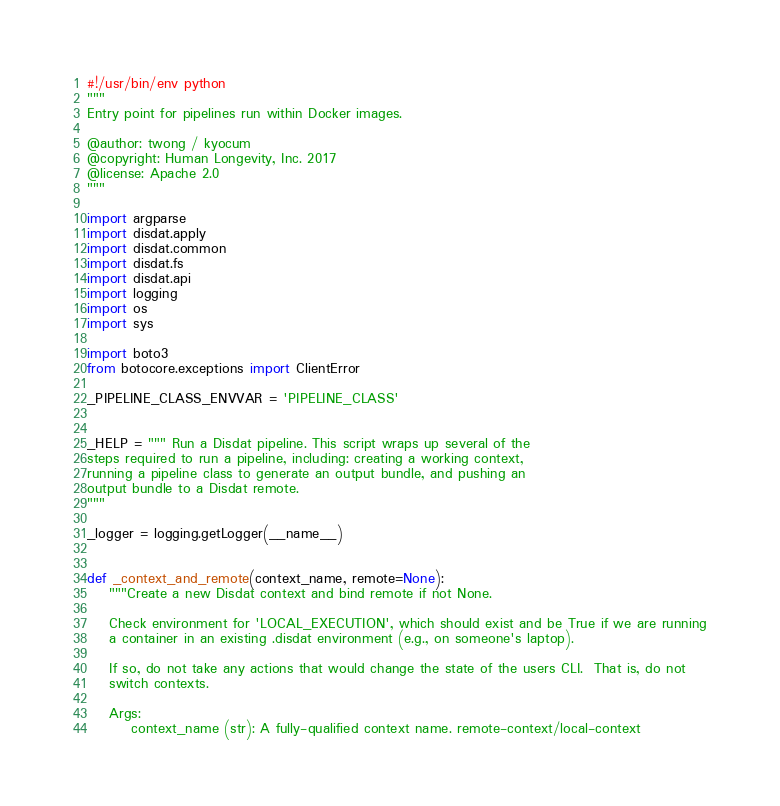Convert code to text. <code><loc_0><loc_0><loc_500><loc_500><_Python_>#!/usr/bin/env python
"""
Entry point for pipelines run within Docker images.

@author: twong / kyocum
@copyright: Human Longevity, Inc. 2017
@license: Apache 2.0
"""

import argparse
import disdat.apply
import disdat.common
import disdat.fs
import disdat.api
import logging
import os
import sys

import boto3
from botocore.exceptions import ClientError

_PIPELINE_CLASS_ENVVAR = 'PIPELINE_CLASS'


_HELP = """ Run a Disdat pipeline. This script wraps up several of the
steps required to run a pipeline, including: creating a working context, 
running a pipeline class to generate an output bundle, and pushing an 
output bundle to a Disdat remote.
"""

_logger = logging.getLogger(__name__)


def _context_and_remote(context_name, remote=None):
    """Create a new Disdat context and bind remote if not None.

    Check environment for 'LOCAL_EXECUTION', which should exist and be True if we are running
    a container in an existing .disdat environment (e.g., on someone's laptop).

    If so, do not take any actions that would change the state of the users CLI.  That is, do not
    switch contexts.

    Args:
        context_name (str): A fully-qualified context name. remote-context/local-context</code> 